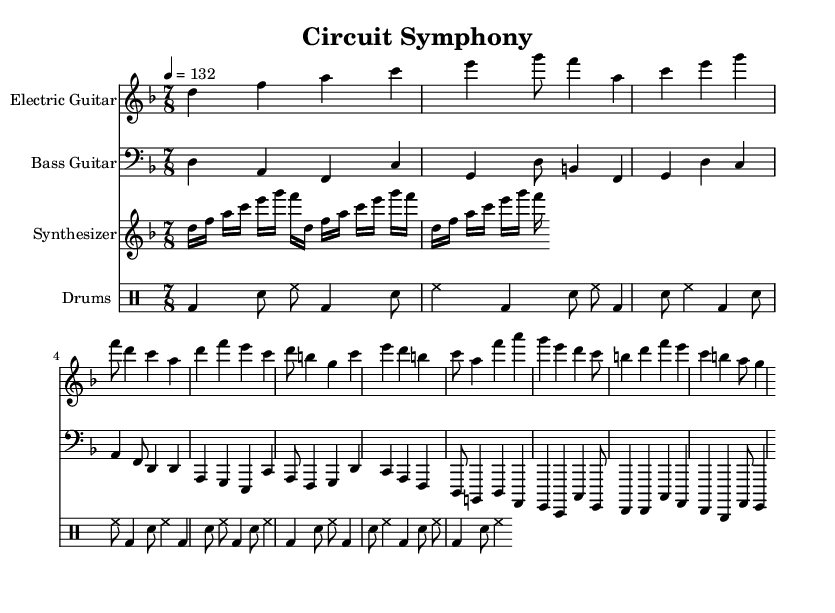What is the key signature of this music? The key signature indicates D minor, which has one flat (B flat). This can be confirmed from the indication given with the key note at the beginning of the score.
Answer: D minor What is the time signature of this music? The time signature is 7/8, which specifies seven eighth notes per measure. This indicates an irregular time signature often found in progressive rock.
Answer: 7/8 What is the tempo marking? The tempo marking is set at 132 BPM, indicated by the tempo directive at the beginning. This specifies how fast the piece should be played, allowing performers to keep a consistent speed.
Answer: 132 How many measures are in the bass guitar part? The bass guitar part contains a total of six measures, which can be counted by visually examining the sections divided by vertical lines on the staff.
Answer: 6 What type of instrument plays the arpeggio pattern? The synthesizer plays the arpeggio pattern, as indicated by its notation and instruction for repeating notes in a specific pattern, typical for electronic ensemble performances.
Answer: Synthesizer What rhythmic pattern is evident in the drum section? The drum section displays a consistent bass drum and snare pattern throughout, common in progressive rock fusion, which creates a driving rhythmic foundation.
Answer: Bass and snare Which instruments contribute to the melodic lines? The electric guitar and synthesizer contribute to the melodic lines in this composition. They each present distinctive melodies that are layered above the rhythmic foundation provided by the bass and drums.
Answer: Electric guitar and synthesizer 